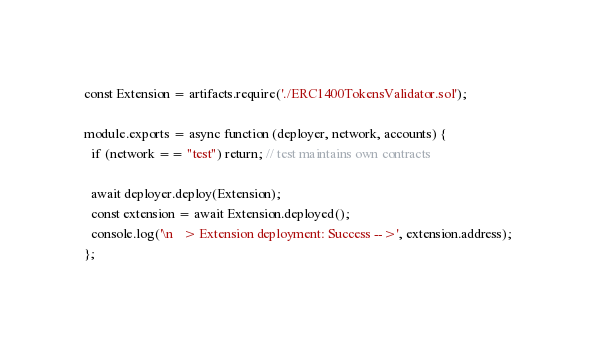<code> <loc_0><loc_0><loc_500><loc_500><_JavaScript_>const Extension = artifacts.require('./ERC1400TokensValidator.sol');

module.exports = async function (deployer, network, accounts) {
  if (network == "test") return; // test maintains own contracts
  
  await deployer.deploy(Extension);
  const extension = await Extension.deployed();
  console.log('\n   > Extension deployment: Success -->', extension.address);
};
</code> 